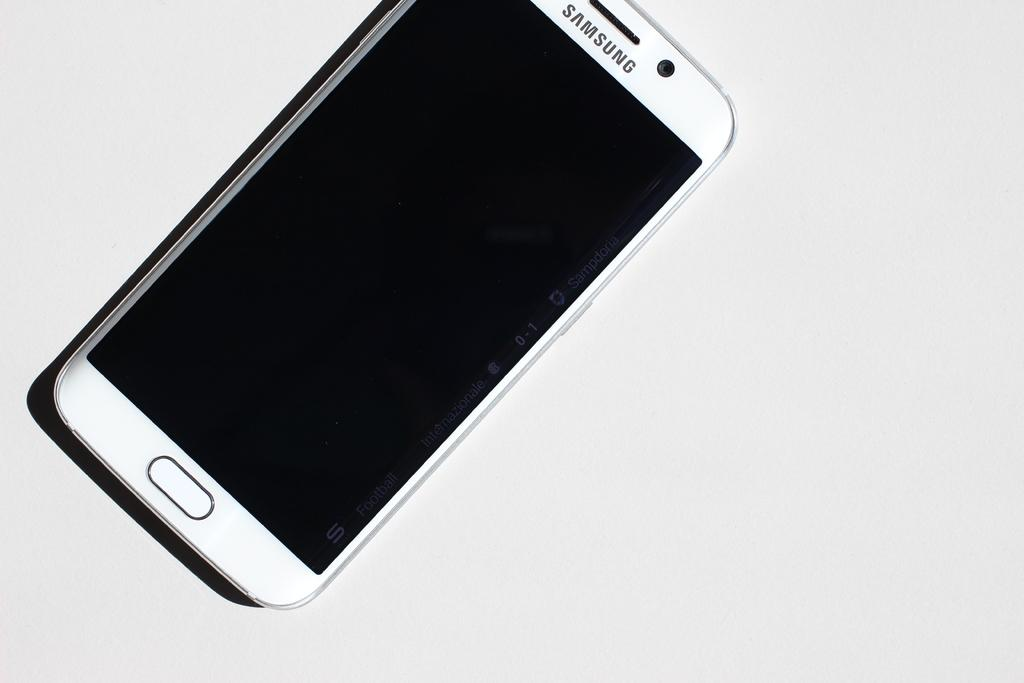<image>
Offer a succinct explanation of the picture presented. A Samsung phone with a black screen sits on a white background. 